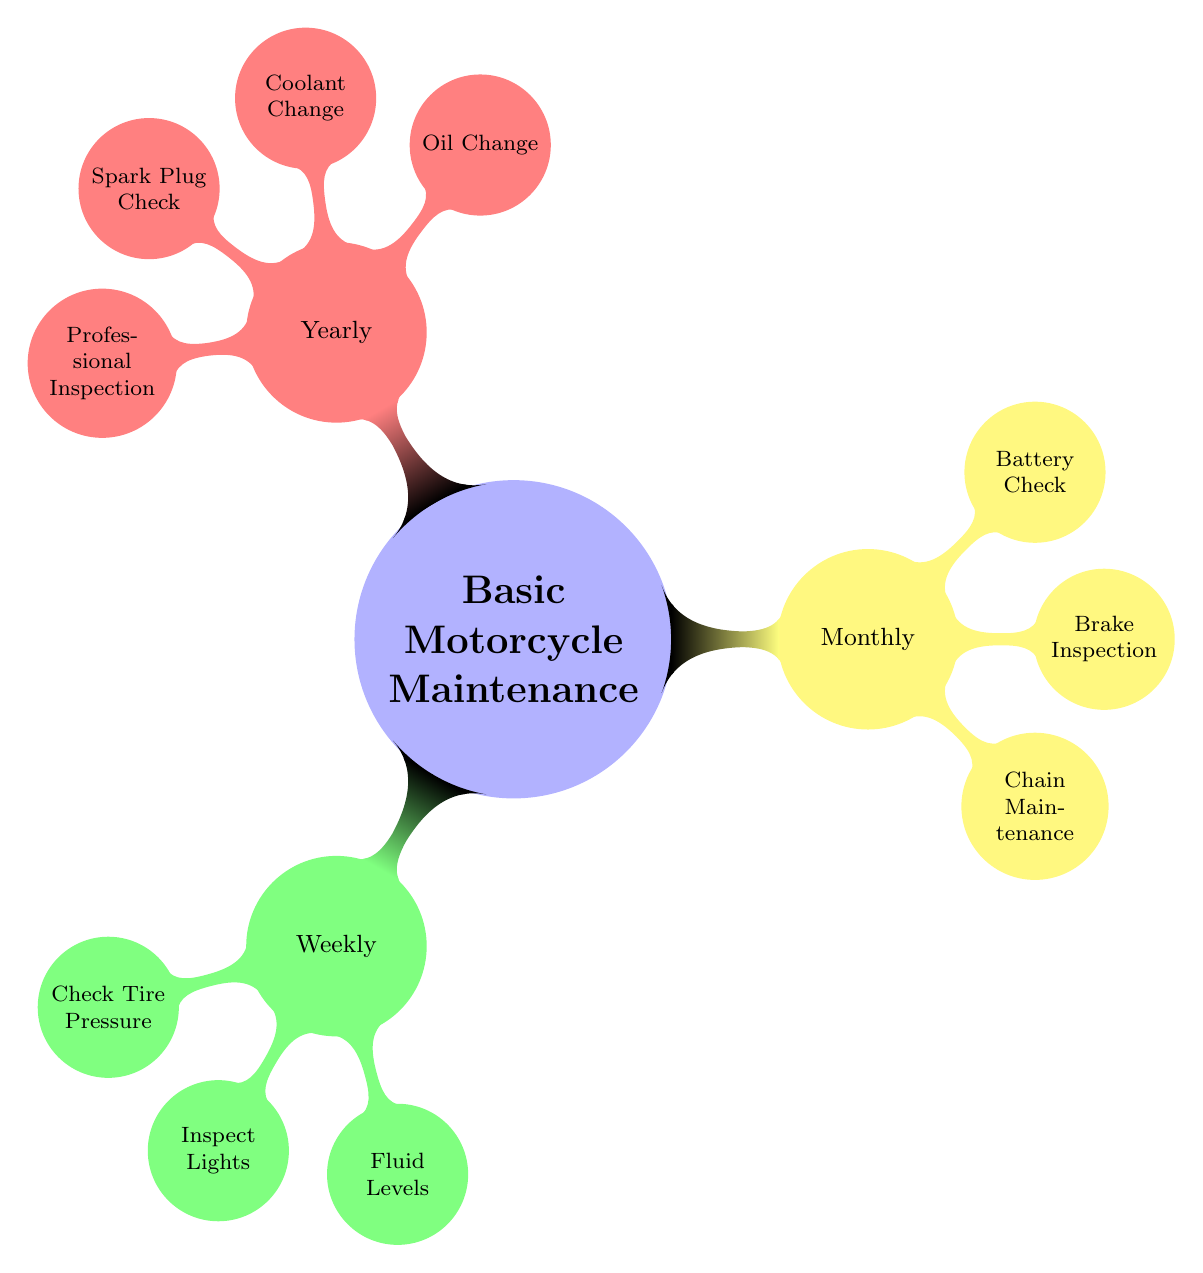What are the main categories of the maintenance schedule? The diagram shows three main categories: Weekly, Monthly, and Yearly. These categorize the maintenance tasks based on their frequency.
Answer: Weekly, Monthly, Yearly How many weekly tasks are listed? In the Weekly section, there are three tasks: Check Tire Pressure, Inspect Lights, and Fluid Levels. Therefore, the total number of weekly tasks is three.
Answer: 3 Which task involves checking fluid levels? The task listed under the Weekly category that involves checking fluid levels is "Fluid Levels." This can be found directly under the Weekly node.
Answer: Fluid Levels What is one task related to battery maintenance? In the Monthly section under Battery Check, one task listed is "Charge Level." This is specifically related to ensuring the battery is functioning correctly.
Answer: Charge Level How many tasks are listed under the Yearly category? The Yearly section has four tasks: Oil Change, Coolant Change, Spark Plug Check, and Professional Inspection. Adding these up gives a total of four tasks.
Answer: 4 What is the relationship between weekly and monthly maintenance? The relationship is that they both are parts of the overall Basic Motorcycle Maintenance Schedule, displaying tasks that need to be done periodically to ensure motorcycle upkeep. Both sections are under the same parent node.
Answer: Periodic maintenance Which task would you perform monthly related to brakes? In the Monthly category, the task related to brakes is "Brake Inspection." This task includes checking brake pads and fluid level.
Answer: Brake Inspection What maintenance task requires the use of a specialized lubricant? Under the Monthly category, the task "Lubricate Chain" specifies the use of a specialized motorcycle chain lubricant. This indicates a specific product required for that maintenance task.
Answer: Lubricate Chain What is the task listed for professional service under Yearly maintenance? The Yearly maintenance section includes "Professional Inspection," which suggests scheduling a comprehensive check-up at an authorized service center.
Answer: Professional Inspection 